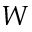Convert formula to latex. <formula><loc_0><loc_0><loc_500><loc_500>W</formula> 